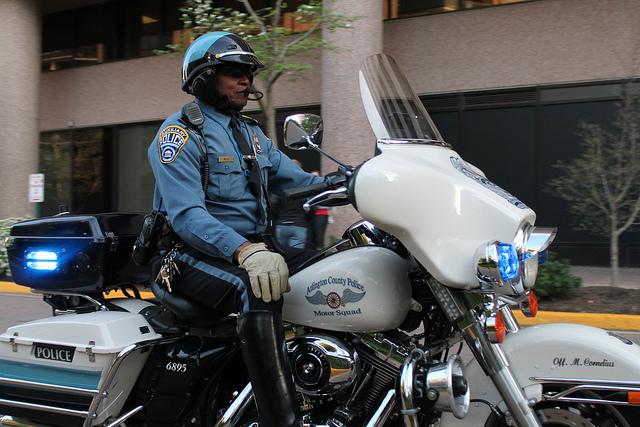What are the people in brown dressed as?
Write a very short answer. Police. Is this person happy?
Answer briefly. No. What color is this person's shirt?
Give a very brief answer. Blue. Is this policeman chasing a car?
Answer briefly. No. 